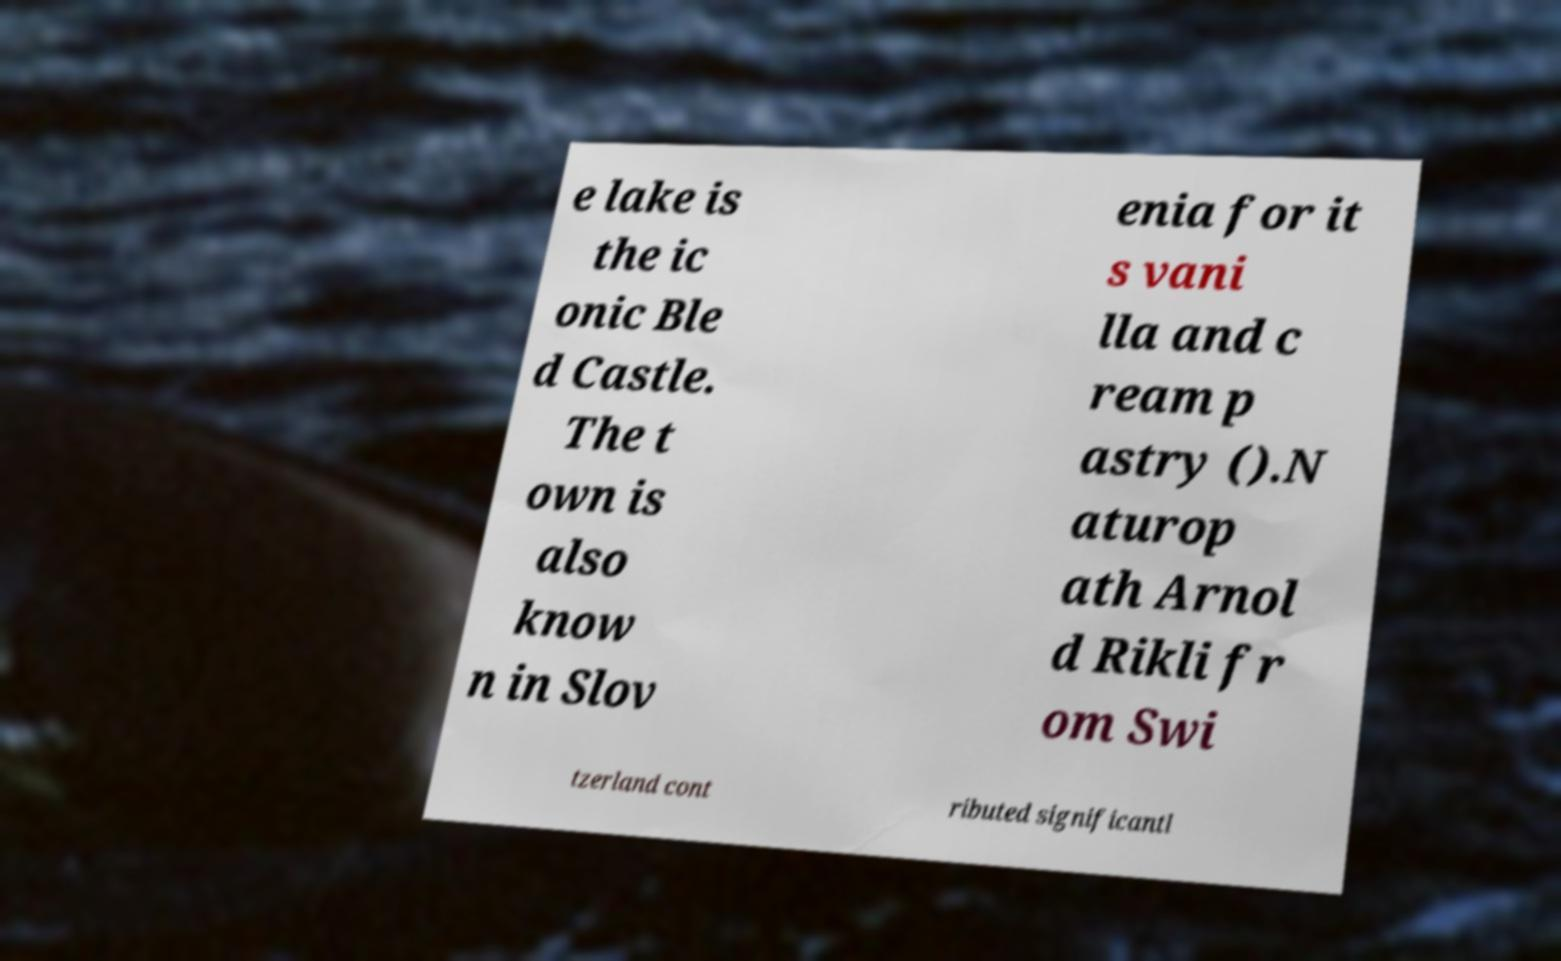Can you read and provide the text displayed in the image?This photo seems to have some interesting text. Can you extract and type it out for me? e lake is the ic onic Ble d Castle. The t own is also know n in Slov enia for it s vani lla and c ream p astry ().N aturop ath Arnol d Rikli fr om Swi tzerland cont ributed significantl 